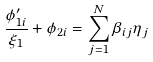<formula> <loc_0><loc_0><loc_500><loc_500>\frac { \phi _ { 1 i } ^ { \prime } } { \xi _ { 1 } } + \phi _ { 2 i } = \sum _ { j = 1 } ^ { N } \beta _ { i j } \eta _ { j }</formula> 